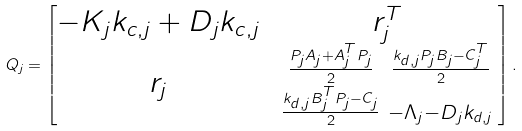Convert formula to latex. <formula><loc_0><loc_0><loc_500><loc_500>Q _ { j } = \begin{bmatrix} - K _ { j } k _ { c , j } + D _ { j } k _ { c , j } & r ^ { T } _ { j } \\ r _ { j } & \begin{smallmatrix} \frac { P _ { j } A _ { j } + A _ { j } ^ { T } P _ { j } } { 2 } & \frac { k _ { d , j } P _ { j } B _ { j } - C _ { j } ^ { T } } { 2 } \\ \frac { k _ { d , j } B ^ { T } _ { j } P _ { j } - C _ { j } } { 2 } & - \Lambda _ { j } - D _ { j } k _ { d , j } \end{smallmatrix} \end{bmatrix} .</formula> 